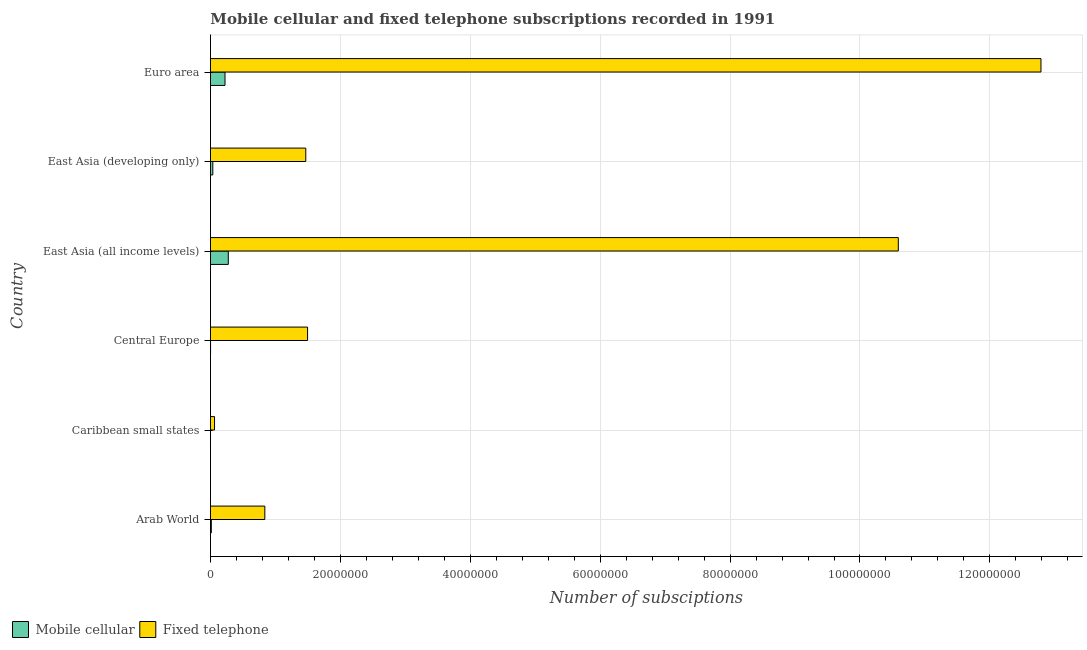How many different coloured bars are there?
Ensure brevity in your answer.  2. Are the number of bars per tick equal to the number of legend labels?
Provide a short and direct response. Yes. Are the number of bars on each tick of the Y-axis equal?
Offer a terse response. Yes. How many bars are there on the 2nd tick from the top?
Keep it short and to the point. 2. How many bars are there on the 1st tick from the bottom?
Offer a very short reply. 2. What is the label of the 4th group of bars from the top?
Your answer should be very brief. Central Europe. In how many cases, is the number of bars for a given country not equal to the number of legend labels?
Your answer should be very brief. 0. What is the number of fixed telephone subscriptions in East Asia (all income levels)?
Provide a succinct answer. 1.06e+08. Across all countries, what is the maximum number of fixed telephone subscriptions?
Ensure brevity in your answer.  1.28e+08. Across all countries, what is the minimum number of fixed telephone subscriptions?
Give a very brief answer. 6.24e+05. In which country was the number of mobile cellular subscriptions minimum?
Give a very brief answer. Caribbean small states. What is the total number of mobile cellular subscriptions in the graph?
Offer a very short reply. 5.49e+06. What is the difference between the number of fixed telephone subscriptions in Caribbean small states and that in East Asia (developing only)?
Provide a short and direct response. -1.40e+07. What is the difference between the number of mobile cellular subscriptions in Euro area and the number of fixed telephone subscriptions in Caribbean small states?
Your response must be concise. 1.62e+06. What is the average number of mobile cellular subscriptions per country?
Offer a very short reply. 9.15e+05. What is the difference between the number of mobile cellular subscriptions and number of fixed telephone subscriptions in Central Europe?
Ensure brevity in your answer.  -1.49e+07. What is the ratio of the number of mobile cellular subscriptions in Arab World to that in East Asia (all income levels)?
Offer a very short reply. 0.05. What is the difference between the highest and the second highest number of mobile cellular subscriptions?
Provide a short and direct response. 5.06e+05. What is the difference between the highest and the lowest number of fixed telephone subscriptions?
Ensure brevity in your answer.  1.27e+08. What does the 1st bar from the top in Central Europe represents?
Ensure brevity in your answer.  Fixed telephone. What does the 2nd bar from the bottom in East Asia (developing only) represents?
Provide a succinct answer. Fixed telephone. How many bars are there?
Provide a short and direct response. 12. Are all the bars in the graph horizontal?
Give a very brief answer. Yes. How many countries are there in the graph?
Offer a very short reply. 6. What is the difference between two consecutive major ticks on the X-axis?
Your answer should be very brief. 2.00e+07. Are the values on the major ticks of X-axis written in scientific E-notation?
Your response must be concise. No. Does the graph contain any zero values?
Offer a terse response. No. Does the graph contain grids?
Your response must be concise. Yes. How many legend labels are there?
Your response must be concise. 2. How are the legend labels stacked?
Offer a very short reply. Horizontal. What is the title of the graph?
Offer a very short reply. Mobile cellular and fixed telephone subscriptions recorded in 1991. What is the label or title of the X-axis?
Offer a terse response. Number of subsciptions. What is the Number of subsciptions of Mobile cellular in Arab World?
Offer a very short reply. 1.30e+05. What is the Number of subsciptions of Fixed telephone in Arab World?
Your answer should be compact. 8.37e+06. What is the Number of subsciptions in Mobile cellular in Caribbean small states?
Ensure brevity in your answer.  5526. What is the Number of subsciptions in Fixed telephone in Caribbean small states?
Offer a terse response. 6.24e+05. What is the Number of subsciptions in Mobile cellular in Central Europe?
Keep it short and to the point. 1.30e+04. What is the Number of subsciptions of Fixed telephone in Central Europe?
Give a very brief answer. 1.49e+07. What is the Number of subsciptions of Mobile cellular in East Asia (all income levels)?
Provide a succinct answer. 2.75e+06. What is the Number of subsciptions of Fixed telephone in East Asia (all income levels)?
Your answer should be very brief. 1.06e+08. What is the Number of subsciptions of Mobile cellular in East Asia (developing only)?
Offer a terse response. 3.60e+05. What is the Number of subsciptions in Fixed telephone in East Asia (developing only)?
Your response must be concise. 1.47e+07. What is the Number of subsciptions of Mobile cellular in Euro area?
Your response must be concise. 2.24e+06. What is the Number of subsciptions in Fixed telephone in Euro area?
Keep it short and to the point. 1.28e+08. Across all countries, what is the maximum Number of subsciptions of Mobile cellular?
Offer a terse response. 2.75e+06. Across all countries, what is the maximum Number of subsciptions in Fixed telephone?
Keep it short and to the point. 1.28e+08. Across all countries, what is the minimum Number of subsciptions of Mobile cellular?
Keep it short and to the point. 5526. Across all countries, what is the minimum Number of subsciptions of Fixed telephone?
Provide a short and direct response. 6.24e+05. What is the total Number of subsciptions of Mobile cellular in the graph?
Make the answer very short. 5.49e+06. What is the total Number of subsciptions in Fixed telephone in the graph?
Ensure brevity in your answer.  2.72e+08. What is the difference between the Number of subsciptions in Mobile cellular in Arab World and that in Caribbean small states?
Ensure brevity in your answer.  1.24e+05. What is the difference between the Number of subsciptions of Fixed telephone in Arab World and that in Caribbean small states?
Your answer should be very brief. 7.75e+06. What is the difference between the Number of subsciptions in Mobile cellular in Arab World and that in Central Europe?
Your answer should be compact. 1.17e+05. What is the difference between the Number of subsciptions of Fixed telephone in Arab World and that in Central Europe?
Make the answer very short. -6.58e+06. What is the difference between the Number of subsciptions in Mobile cellular in Arab World and that in East Asia (all income levels)?
Provide a short and direct response. -2.62e+06. What is the difference between the Number of subsciptions of Fixed telephone in Arab World and that in East Asia (all income levels)?
Offer a terse response. -9.75e+07. What is the difference between the Number of subsciptions of Mobile cellular in Arab World and that in East Asia (developing only)?
Ensure brevity in your answer.  -2.30e+05. What is the difference between the Number of subsciptions in Fixed telephone in Arab World and that in East Asia (developing only)?
Your answer should be very brief. -6.30e+06. What is the difference between the Number of subsciptions in Mobile cellular in Arab World and that in Euro area?
Offer a very short reply. -2.11e+06. What is the difference between the Number of subsciptions in Fixed telephone in Arab World and that in Euro area?
Your answer should be compact. -1.19e+08. What is the difference between the Number of subsciptions of Mobile cellular in Caribbean small states and that in Central Europe?
Ensure brevity in your answer.  -7424. What is the difference between the Number of subsciptions of Fixed telephone in Caribbean small states and that in Central Europe?
Your answer should be compact. -1.43e+07. What is the difference between the Number of subsciptions of Mobile cellular in Caribbean small states and that in East Asia (all income levels)?
Keep it short and to the point. -2.74e+06. What is the difference between the Number of subsciptions of Fixed telephone in Caribbean small states and that in East Asia (all income levels)?
Your answer should be compact. -1.05e+08. What is the difference between the Number of subsciptions in Mobile cellular in Caribbean small states and that in East Asia (developing only)?
Make the answer very short. -3.55e+05. What is the difference between the Number of subsciptions of Fixed telephone in Caribbean small states and that in East Asia (developing only)?
Your response must be concise. -1.40e+07. What is the difference between the Number of subsciptions in Mobile cellular in Caribbean small states and that in Euro area?
Provide a succinct answer. -2.23e+06. What is the difference between the Number of subsciptions in Fixed telephone in Caribbean small states and that in Euro area?
Your answer should be very brief. -1.27e+08. What is the difference between the Number of subsciptions in Mobile cellular in Central Europe and that in East Asia (all income levels)?
Give a very brief answer. -2.73e+06. What is the difference between the Number of subsciptions in Fixed telephone in Central Europe and that in East Asia (all income levels)?
Your answer should be very brief. -9.10e+07. What is the difference between the Number of subsciptions in Mobile cellular in Central Europe and that in East Asia (developing only)?
Give a very brief answer. -3.47e+05. What is the difference between the Number of subsciptions of Fixed telephone in Central Europe and that in East Asia (developing only)?
Keep it short and to the point. 2.76e+05. What is the difference between the Number of subsciptions in Mobile cellular in Central Europe and that in Euro area?
Give a very brief answer. -2.23e+06. What is the difference between the Number of subsciptions of Fixed telephone in Central Europe and that in Euro area?
Provide a succinct answer. -1.13e+08. What is the difference between the Number of subsciptions of Mobile cellular in East Asia (all income levels) and that in East Asia (developing only)?
Your answer should be compact. 2.39e+06. What is the difference between the Number of subsciptions of Fixed telephone in East Asia (all income levels) and that in East Asia (developing only)?
Provide a succinct answer. 9.12e+07. What is the difference between the Number of subsciptions in Mobile cellular in East Asia (all income levels) and that in Euro area?
Ensure brevity in your answer.  5.06e+05. What is the difference between the Number of subsciptions in Fixed telephone in East Asia (all income levels) and that in Euro area?
Your answer should be compact. -2.20e+07. What is the difference between the Number of subsciptions in Mobile cellular in East Asia (developing only) and that in Euro area?
Keep it short and to the point. -1.88e+06. What is the difference between the Number of subsciptions in Fixed telephone in East Asia (developing only) and that in Euro area?
Offer a very short reply. -1.13e+08. What is the difference between the Number of subsciptions in Mobile cellular in Arab World and the Number of subsciptions in Fixed telephone in Caribbean small states?
Ensure brevity in your answer.  -4.94e+05. What is the difference between the Number of subsciptions in Mobile cellular in Arab World and the Number of subsciptions in Fixed telephone in Central Europe?
Your response must be concise. -1.48e+07. What is the difference between the Number of subsciptions in Mobile cellular in Arab World and the Number of subsciptions in Fixed telephone in East Asia (all income levels)?
Provide a succinct answer. -1.06e+08. What is the difference between the Number of subsciptions of Mobile cellular in Arab World and the Number of subsciptions of Fixed telephone in East Asia (developing only)?
Your response must be concise. -1.45e+07. What is the difference between the Number of subsciptions of Mobile cellular in Arab World and the Number of subsciptions of Fixed telephone in Euro area?
Offer a terse response. -1.28e+08. What is the difference between the Number of subsciptions of Mobile cellular in Caribbean small states and the Number of subsciptions of Fixed telephone in Central Europe?
Give a very brief answer. -1.49e+07. What is the difference between the Number of subsciptions in Mobile cellular in Caribbean small states and the Number of subsciptions in Fixed telephone in East Asia (all income levels)?
Provide a succinct answer. -1.06e+08. What is the difference between the Number of subsciptions of Mobile cellular in Caribbean small states and the Number of subsciptions of Fixed telephone in East Asia (developing only)?
Offer a very short reply. -1.47e+07. What is the difference between the Number of subsciptions of Mobile cellular in Caribbean small states and the Number of subsciptions of Fixed telephone in Euro area?
Ensure brevity in your answer.  -1.28e+08. What is the difference between the Number of subsciptions in Mobile cellular in Central Europe and the Number of subsciptions in Fixed telephone in East Asia (all income levels)?
Your answer should be compact. -1.06e+08. What is the difference between the Number of subsciptions in Mobile cellular in Central Europe and the Number of subsciptions in Fixed telephone in East Asia (developing only)?
Offer a very short reply. -1.47e+07. What is the difference between the Number of subsciptions of Mobile cellular in Central Europe and the Number of subsciptions of Fixed telephone in Euro area?
Ensure brevity in your answer.  -1.28e+08. What is the difference between the Number of subsciptions in Mobile cellular in East Asia (all income levels) and the Number of subsciptions in Fixed telephone in East Asia (developing only)?
Your answer should be compact. -1.19e+07. What is the difference between the Number of subsciptions of Mobile cellular in East Asia (all income levels) and the Number of subsciptions of Fixed telephone in Euro area?
Provide a short and direct response. -1.25e+08. What is the difference between the Number of subsciptions in Mobile cellular in East Asia (developing only) and the Number of subsciptions in Fixed telephone in Euro area?
Your response must be concise. -1.28e+08. What is the average Number of subsciptions of Mobile cellular per country?
Your answer should be very brief. 9.15e+05. What is the average Number of subsciptions in Fixed telephone per country?
Provide a succinct answer. 4.54e+07. What is the difference between the Number of subsciptions of Mobile cellular and Number of subsciptions of Fixed telephone in Arab World?
Offer a very short reply. -8.24e+06. What is the difference between the Number of subsciptions of Mobile cellular and Number of subsciptions of Fixed telephone in Caribbean small states?
Offer a very short reply. -6.18e+05. What is the difference between the Number of subsciptions in Mobile cellular and Number of subsciptions in Fixed telephone in Central Europe?
Ensure brevity in your answer.  -1.49e+07. What is the difference between the Number of subsciptions of Mobile cellular and Number of subsciptions of Fixed telephone in East Asia (all income levels)?
Your answer should be compact. -1.03e+08. What is the difference between the Number of subsciptions in Mobile cellular and Number of subsciptions in Fixed telephone in East Asia (developing only)?
Your answer should be very brief. -1.43e+07. What is the difference between the Number of subsciptions of Mobile cellular and Number of subsciptions of Fixed telephone in Euro area?
Make the answer very short. -1.26e+08. What is the ratio of the Number of subsciptions of Mobile cellular in Arab World to that in Caribbean small states?
Provide a succinct answer. 23.51. What is the ratio of the Number of subsciptions of Fixed telephone in Arab World to that in Caribbean small states?
Ensure brevity in your answer.  13.42. What is the ratio of the Number of subsciptions in Mobile cellular in Arab World to that in Central Europe?
Your answer should be compact. 10.03. What is the ratio of the Number of subsciptions of Fixed telephone in Arab World to that in Central Europe?
Ensure brevity in your answer.  0.56. What is the ratio of the Number of subsciptions of Mobile cellular in Arab World to that in East Asia (all income levels)?
Your response must be concise. 0.05. What is the ratio of the Number of subsciptions in Fixed telephone in Arab World to that in East Asia (all income levels)?
Provide a succinct answer. 0.08. What is the ratio of the Number of subsciptions of Mobile cellular in Arab World to that in East Asia (developing only)?
Offer a very short reply. 0.36. What is the ratio of the Number of subsciptions of Fixed telephone in Arab World to that in East Asia (developing only)?
Your response must be concise. 0.57. What is the ratio of the Number of subsciptions of Mobile cellular in Arab World to that in Euro area?
Keep it short and to the point. 0.06. What is the ratio of the Number of subsciptions in Fixed telephone in Arab World to that in Euro area?
Your answer should be compact. 0.07. What is the ratio of the Number of subsciptions of Mobile cellular in Caribbean small states to that in Central Europe?
Provide a short and direct response. 0.43. What is the ratio of the Number of subsciptions of Fixed telephone in Caribbean small states to that in Central Europe?
Ensure brevity in your answer.  0.04. What is the ratio of the Number of subsciptions of Mobile cellular in Caribbean small states to that in East Asia (all income levels)?
Offer a very short reply. 0. What is the ratio of the Number of subsciptions in Fixed telephone in Caribbean small states to that in East Asia (all income levels)?
Provide a short and direct response. 0.01. What is the ratio of the Number of subsciptions of Mobile cellular in Caribbean small states to that in East Asia (developing only)?
Offer a terse response. 0.02. What is the ratio of the Number of subsciptions in Fixed telephone in Caribbean small states to that in East Asia (developing only)?
Your answer should be very brief. 0.04. What is the ratio of the Number of subsciptions in Mobile cellular in Caribbean small states to that in Euro area?
Your answer should be very brief. 0. What is the ratio of the Number of subsciptions in Fixed telephone in Caribbean small states to that in Euro area?
Provide a short and direct response. 0. What is the ratio of the Number of subsciptions of Mobile cellular in Central Europe to that in East Asia (all income levels)?
Provide a short and direct response. 0. What is the ratio of the Number of subsciptions in Fixed telephone in Central Europe to that in East Asia (all income levels)?
Keep it short and to the point. 0.14. What is the ratio of the Number of subsciptions of Mobile cellular in Central Europe to that in East Asia (developing only)?
Provide a short and direct response. 0.04. What is the ratio of the Number of subsciptions in Fixed telephone in Central Europe to that in East Asia (developing only)?
Provide a short and direct response. 1.02. What is the ratio of the Number of subsciptions of Mobile cellular in Central Europe to that in Euro area?
Make the answer very short. 0.01. What is the ratio of the Number of subsciptions in Fixed telephone in Central Europe to that in Euro area?
Your answer should be compact. 0.12. What is the ratio of the Number of subsciptions of Mobile cellular in East Asia (all income levels) to that in East Asia (developing only)?
Your answer should be compact. 7.62. What is the ratio of the Number of subsciptions of Fixed telephone in East Asia (all income levels) to that in East Asia (developing only)?
Offer a very short reply. 7.22. What is the ratio of the Number of subsciptions in Mobile cellular in East Asia (all income levels) to that in Euro area?
Keep it short and to the point. 1.23. What is the ratio of the Number of subsciptions in Fixed telephone in East Asia (all income levels) to that in Euro area?
Your answer should be very brief. 0.83. What is the ratio of the Number of subsciptions of Mobile cellular in East Asia (developing only) to that in Euro area?
Offer a very short reply. 0.16. What is the ratio of the Number of subsciptions in Fixed telephone in East Asia (developing only) to that in Euro area?
Offer a terse response. 0.11. What is the difference between the highest and the second highest Number of subsciptions of Mobile cellular?
Keep it short and to the point. 5.06e+05. What is the difference between the highest and the second highest Number of subsciptions in Fixed telephone?
Your answer should be compact. 2.20e+07. What is the difference between the highest and the lowest Number of subsciptions in Mobile cellular?
Give a very brief answer. 2.74e+06. What is the difference between the highest and the lowest Number of subsciptions in Fixed telephone?
Your answer should be very brief. 1.27e+08. 